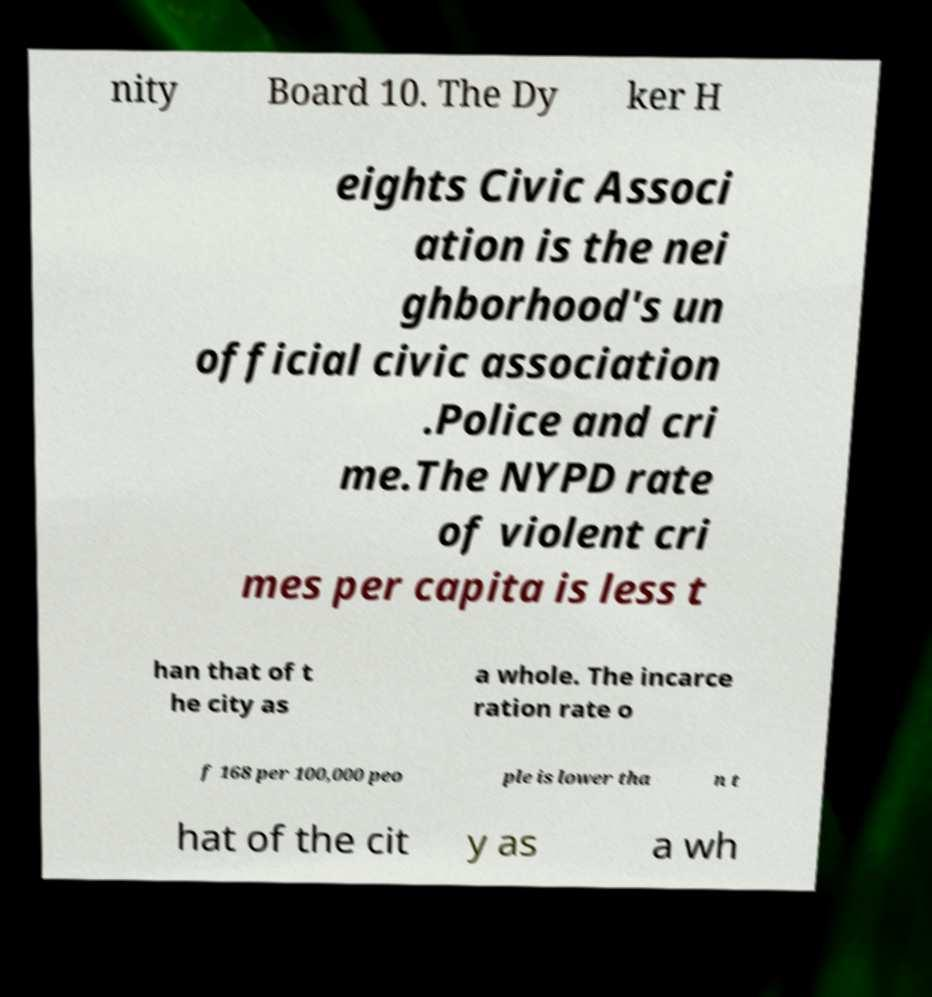Can you read and provide the text displayed in the image?This photo seems to have some interesting text. Can you extract and type it out for me? nity Board 10. The Dy ker H eights Civic Associ ation is the nei ghborhood's un official civic association .Police and cri me.The NYPD rate of violent cri mes per capita is less t han that of t he city as a whole. The incarce ration rate o f 168 per 100,000 peo ple is lower tha n t hat of the cit y as a wh 